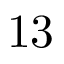<formula> <loc_0><loc_0><loc_500><loc_500>1 3</formula> 